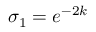<formula> <loc_0><loc_0><loc_500><loc_500>\sigma _ { 1 } = e ^ { - 2 k }</formula> 